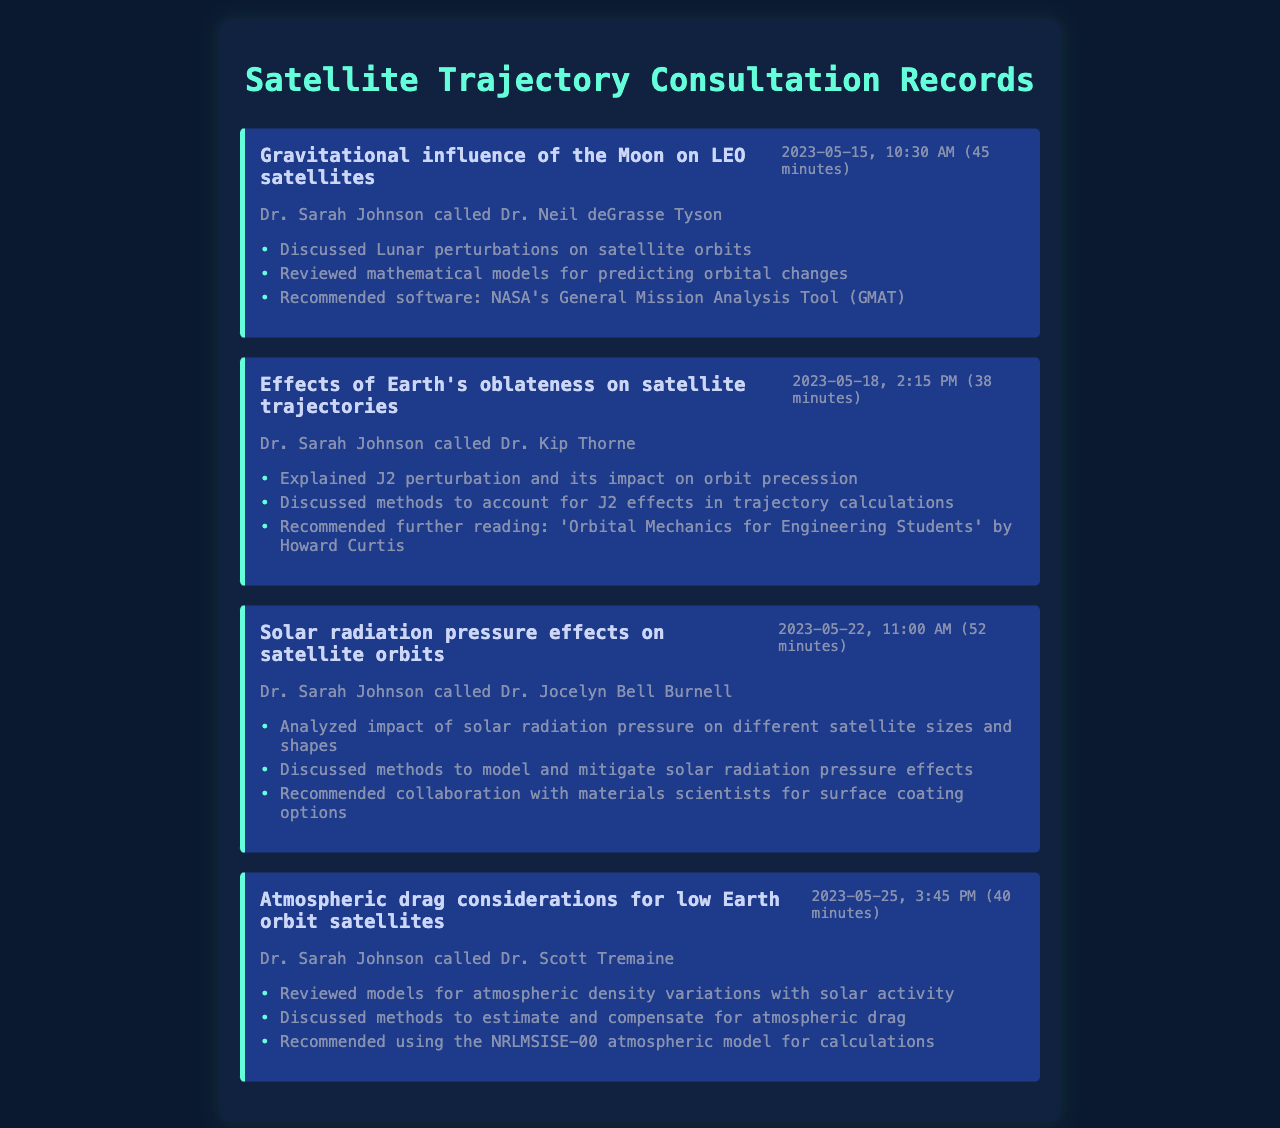What was the date of the consultation regarding the Moon's influence on LEO satellites? The date is found in the details of the first record.
Answer: 2023-05-15 Who did Dr. Sarah Johnson consult with about Earth's oblateness? The document specifies the person she called in the details of the second record.
Answer: Dr. Kip Thorne How long was the consultation on solar radiation pressure effects? The duration is mentioned in the details of the third record.
Answer: 52 minutes What mathematical tool was recommended for lunar perturbation predictions? This information is mentioned in the key points of the first record.
Answer: NASA's General Mission Analysis Tool (GMAT) Which atmospheric model was suggested for drag calculations? This model is noted in the key points of the fourth record.
Answer: NRLMSISE-00 What was discussed regarding atmospheric density variations? The document notes this topic in the key points of the fourth record.
Answer: Solar activity Which cosmologist discussed J2 perturbation impacts? The document provides the name in the second record.
Answer: Dr. Kip Thorne What is the main topic of the third consultation? The title of the third record provides this information.
Answer: Solar radiation pressure effects on satellite orbits What was advised for surface coating options in relation to solar radiation pressure? This recommendation is found in the key points of the third record.
Answer: Collaboration with materials scientists 